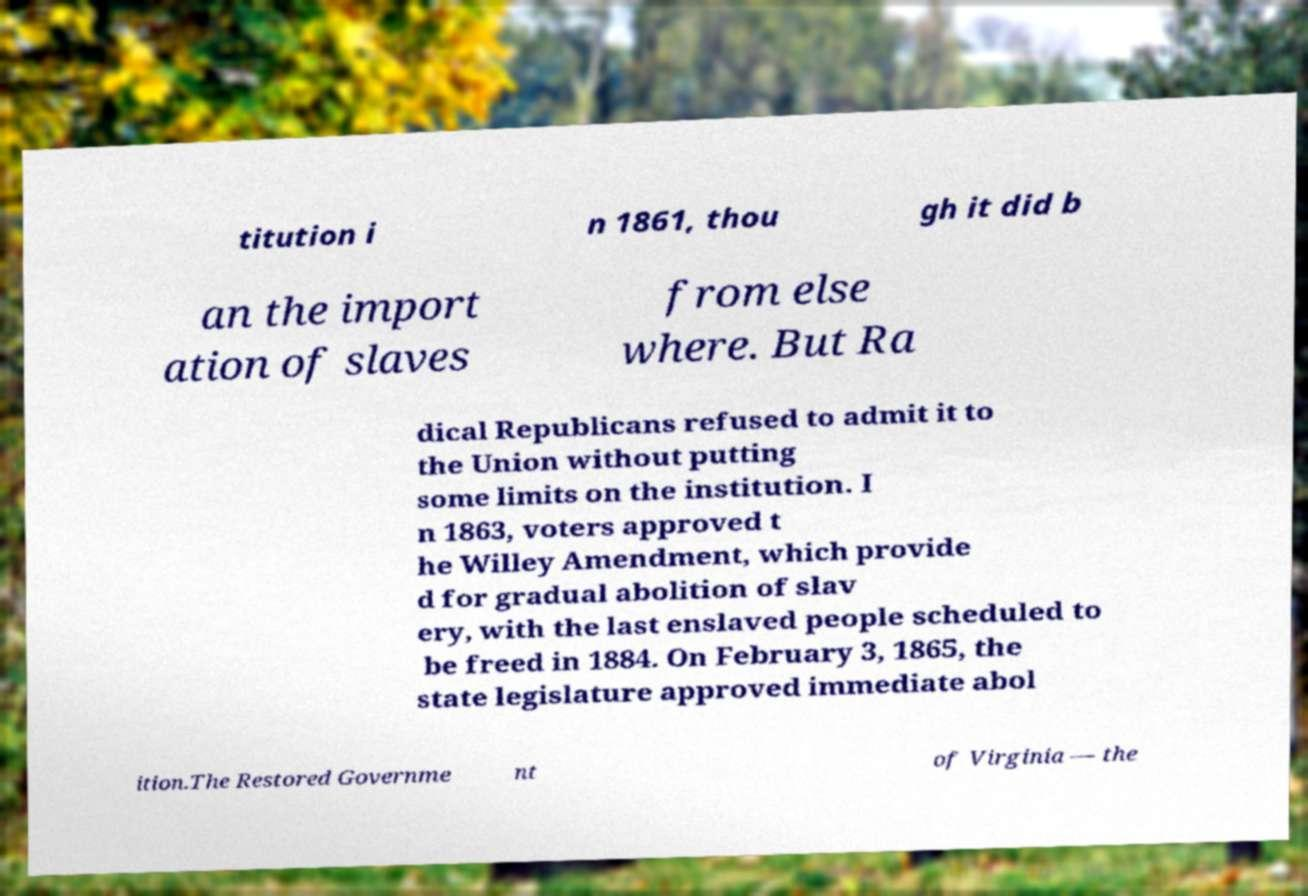I need the written content from this picture converted into text. Can you do that? titution i n 1861, thou gh it did b an the import ation of slaves from else where. But Ra dical Republicans refused to admit it to the Union without putting some limits on the institution. I n 1863, voters approved t he Willey Amendment, which provide d for gradual abolition of slav ery, with the last enslaved people scheduled to be freed in 1884. On February 3, 1865, the state legislature approved immediate abol ition.The Restored Governme nt of Virginia — the 